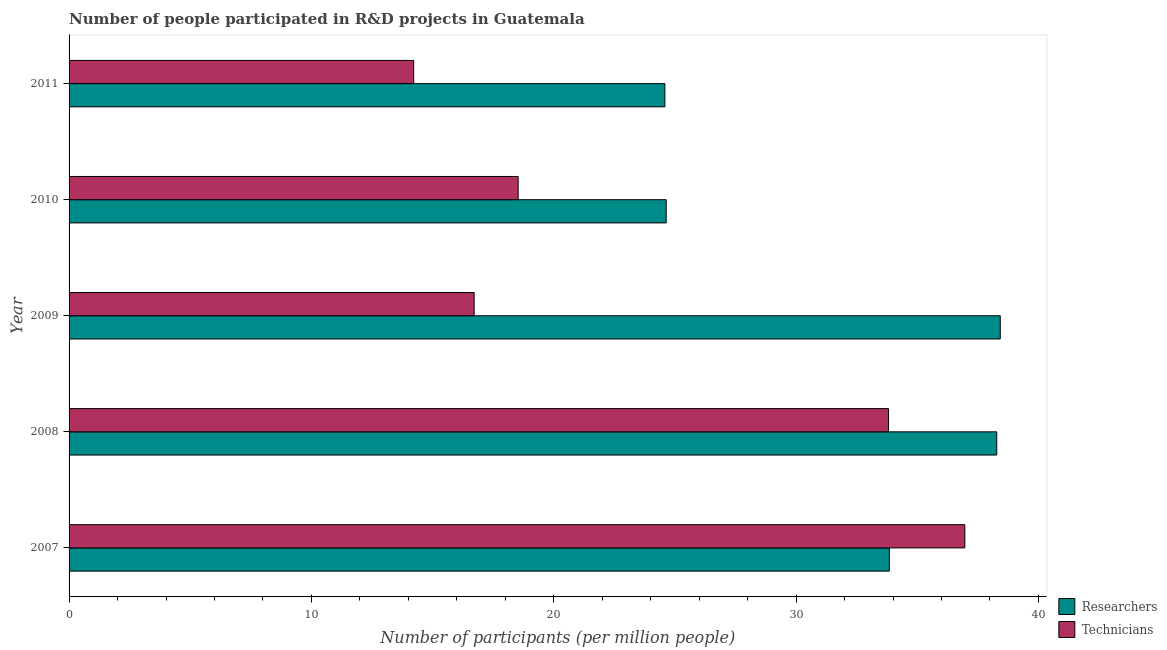How many different coloured bars are there?
Your answer should be compact. 2. How many groups of bars are there?
Offer a very short reply. 5. Are the number of bars per tick equal to the number of legend labels?
Offer a very short reply. Yes. Are the number of bars on each tick of the Y-axis equal?
Keep it short and to the point. Yes. How many bars are there on the 3rd tick from the bottom?
Your answer should be very brief. 2. What is the number of technicians in 2008?
Provide a succinct answer. 33.81. Across all years, what is the maximum number of researchers?
Give a very brief answer. 38.42. Across all years, what is the minimum number of technicians?
Offer a very short reply. 14.22. In which year was the number of researchers maximum?
Keep it short and to the point. 2009. What is the total number of researchers in the graph?
Keep it short and to the point. 159.78. What is the difference between the number of technicians in 2007 and that in 2009?
Your answer should be compact. 20.25. What is the difference between the number of researchers in 2011 and the number of technicians in 2009?
Provide a short and direct response. 7.87. What is the average number of researchers per year?
Your response must be concise. 31.95. In the year 2007, what is the difference between the number of researchers and number of technicians?
Provide a succinct answer. -3.12. In how many years, is the number of technicians greater than 2 ?
Make the answer very short. 5. What is the ratio of the number of technicians in 2007 to that in 2008?
Provide a succinct answer. 1.09. Is the number of technicians in 2009 less than that in 2011?
Your answer should be compact. No. Is the difference between the number of technicians in 2008 and 2011 greater than the difference between the number of researchers in 2008 and 2011?
Provide a short and direct response. Yes. What is the difference between the highest and the second highest number of researchers?
Your response must be concise. 0.14. What is the difference between the highest and the lowest number of technicians?
Keep it short and to the point. 22.74. What does the 1st bar from the top in 2011 represents?
Provide a succinct answer. Technicians. What does the 2nd bar from the bottom in 2010 represents?
Offer a very short reply. Technicians. Are all the bars in the graph horizontal?
Offer a terse response. Yes. What is the difference between two consecutive major ticks on the X-axis?
Ensure brevity in your answer.  10. Are the values on the major ticks of X-axis written in scientific E-notation?
Provide a succinct answer. No. Does the graph contain any zero values?
Your answer should be very brief. No. Does the graph contain grids?
Provide a succinct answer. No. Where does the legend appear in the graph?
Ensure brevity in your answer.  Bottom right. How many legend labels are there?
Ensure brevity in your answer.  2. How are the legend labels stacked?
Offer a terse response. Vertical. What is the title of the graph?
Your answer should be very brief. Number of people participated in R&D projects in Guatemala. What is the label or title of the X-axis?
Provide a succinct answer. Number of participants (per million people). What is the Number of participants (per million people) of Researchers in 2007?
Offer a very short reply. 33.85. What is the Number of participants (per million people) in Technicians in 2007?
Provide a short and direct response. 36.96. What is the Number of participants (per million people) in Researchers in 2008?
Keep it short and to the point. 38.28. What is the Number of participants (per million people) in Technicians in 2008?
Offer a very short reply. 33.81. What is the Number of participants (per million people) in Researchers in 2009?
Your answer should be very brief. 38.42. What is the Number of participants (per million people) of Technicians in 2009?
Your response must be concise. 16.72. What is the Number of participants (per million people) in Researchers in 2010?
Offer a terse response. 24.64. What is the Number of participants (per million people) of Technicians in 2010?
Your answer should be very brief. 18.53. What is the Number of participants (per million people) in Researchers in 2011?
Ensure brevity in your answer.  24.59. What is the Number of participants (per million people) in Technicians in 2011?
Provide a short and direct response. 14.22. Across all years, what is the maximum Number of participants (per million people) in Researchers?
Ensure brevity in your answer.  38.42. Across all years, what is the maximum Number of participants (per million people) in Technicians?
Offer a very short reply. 36.96. Across all years, what is the minimum Number of participants (per million people) of Researchers?
Offer a terse response. 24.59. Across all years, what is the minimum Number of participants (per million people) in Technicians?
Your answer should be very brief. 14.22. What is the total Number of participants (per million people) in Researchers in the graph?
Your response must be concise. 159.78. What is the total Number of participants (per million people) in Technicians in the graph?
Provide a short and direct response. 120.24. What is the difference between the Number of participants (per million people) of Researchers in 2007 and that in 2008?
Your answer should be compact. -4.43. What is the difference between the Number of participants (per million people) of Technicians in 2007 and that in 2008?
Provide a succinct answer. 3.15. What is the difference between the Number of participants (per million people) in Researchers in 2007 and that in 2009?
Give a very brief answer. -4.58. What is the difference between the Number of participants (per million people) of Technicians in 2007 and that in 2009?
Offer a terse response. 20.25. What is the difference between the Number of participants (per million people) of Researchers in 2007 and that in 2010?
Provide a succinct answer. 9.21. What is the difference between the Number of participants (per million people) of Technicians in 2007 and that in 2010?
Give a very brief answer. 18.43. What is the difference between the Number of participants (per million people) of Researchers in 2007 and that in 2011?
Your answer should be very brief. 9.26. What is the difference between the Number of participants (per million people) of Technicians in 2007 and that in 2011?
Your answer should be very brief. 22.74. What is the difference between the Number of participants (per million people) of Researchers in 2008 and that in 2009?
Your response must be concise. -0.14. What is the difference between the Number of participants (per million people) of Technicians in 2008 and that in 2009?
Give a very brief answer. 17.1. What is the difference between the Number of participants (per million people) in Researchers in 2008 and that in 2010?
Give a very brief answer. 13.64. What is the difference between the Number of participants (per million people) in Technicians in 2008 and that in 2010?
Give a very brief answer. 15.28. What is the difference between the Number of participants (per million people) in Researchers in 2008 and that in 2011?
Provide a short and direct response. 13.69. What is the difference between the Number of participants (per million people) in Technicians in 2008 and that in 2011?
Offer a terse response. 19.59. What is the difference between the Number of participants (per million people) of Researchers in 2009 and that in 2010?
Keep it short and to the point. 13.78. What is the difference between the Number of participants (per million people) in Technicians in 2009 and that in 2010?
Your answer should be compact. -1.82. What is the difference between the Number of participants (per million people) of Researchers in 2009 and that in 2011?
Keep it short and to the point. 13.84. What is the difference between the Number of participants (per million people) in Technicians in 2009 and that in 2011?
Your response must be concise. 2.5. What is the difference between the Number of participants (per million people) in Researchers in 2010 and that in 2011?
Your answer should be compact. 0.05. What is the difference between the Number of participants (per million people) in Technicians in 2010 and that in 2011?
Ensure brevity in your answer.  4.31. What is the difference between the Number of participants (per million people) in Researchers in 2007 and the Number of participants (per million people) in Technicians in 2008?
Offer a terse response. 0.03. What is the difference between the Number of participants (per million people) in Researchers in 2007 and the Number of participants (per million people) in Technicians in 2009?
Make the answer very short. 17.13. What is the difference between the Number of participants (per million people) in Researchers in 2007 and the Number of participants (per million people) in Technicians in 2010?
Make the answer very short. 15.32. What is the difference between the Number of participants (per million people) of Researchers in 2007 and the Number of participants (per million people) of Technicians in 2011?
Provide a short and direct response. 19.63. What is the difference between the Number of participants (per million people) of Researchers in 2008 and the Number of participants (per million people) of Technicians in 2009?
Your response must be concise. 21.56. What is the difference between the Number of participants (per million people) in Researchers in 2008 and the Number of participants (per million people) in Technicians in 2010?
Your answer should be very brief. 19.75. What is the difference between the Number of participants (per million people) in Researchers in 2008 and the Number of participants (per million people) in Technicians in 2011?
Provide a short and direct response. 24.06. What is the difference between the Number of participants (per million people) of Researchers in 2009 and the Number of participants (per million people) of Technicians in 2010?
Ensure brevity in your answer.  19.89. What is the difference between the Number of participants (per million people) of Researchers in 2009 and the Number of participants (per million people) of Technicians in 2011?
Your answer should be very brief. 24.2. What is the difference between the Number of participants (per million people) in Researchers in 2010 and the Number of participants (per million people) in Technicians in 2011?
Provide a succinct answer. 10.42. What is the average Number of participants (per million people) in Researchers per year?
Offer a very short reply. 31.96. What is the average Number of participants (per million people) of Technicians per year?
Provide a short and direct response. 24.05. In the year 2007, what is the difference between the Number of participants (per million people) in Researchers and Number of participants (per million people) in Technicians?
Your answer should be compact. -3.12. In the year 2008, what is the difference between the Number of participants (per million people) of Researchers and Number of participants (per million people) of Technicians?
Your answer should be very brief. 4.47. In the year 2009, what is the difference between the Number of participants (per million people) in Researchers and Number of participants (per million people) in Technicians?
Your response must be concise. 21.71. In the year 2010, what is the difference between the Number of participants (per million people) in Researchers and Number of participants (per million people) in Technicians?
Offer a very short reply. 6.11. In the year 2011, what is the difference between the Number of participants (per million people) in Researchers and Number of participants (per million people) in Technicians?
Offer a very short reply. 10.37. What is the ratio of the Number of participants (per million people) in Researchers in 2007 to that in 2008?
Make the answer very short. 0.88. What is the ratio of the Number of participants (per million people) in Technicians in 2007 to that in 2008?
Your answer should be very brief. 1.09. What is the ratio of the Number of participants (per million people) in Researchers in 2007 to that in 2009?
Provide a succinct answer. 0.88. What is the ratio of the Number of participants (per million people) in Technicians in 2007 to that in 2009?
Provide a short and direct response. 2.21. What is the ratio of the Number of participants (per million people) of Researchers in 2007 to that in 2010?
Provide a short and direct response. 1.37. What is the ratio of the Number of participants (per million people) of Technicians in 2007 to that in 2010?
Your answer should be very brief. 1.99. What is the ratio of the Number of participants (per million people) of Researchers in 2007 to that in 2011?
Offer a terse response. 1.38. What is the ratio of the Number of participants (per million people) in Technicians in 2007 to that in 2011?
Your answer should be very brief. 2.6. What is the ratio of the Number of participants (per million people) of Researchers in 2008 to that in 2009?
Provide a short and direct response. 1. What is the ratio of the Number of participants (per million people) of Technicians in 2008 to that in 2009?
Your answer should be compact. 2.02. What is the ratio of the Number of participants (per million people) in Researchers in 2008 to that in 2010?
Offer a very short reply. 1.55. What is the ratio of the Number of participants (per million people) in Technicians in 2008 to that in 2010?
Provide a succinct answer. 1.82. What is the ratio of the Number of participants (per million people) in Researchers in 2008 to that in 2011?
Offer a very short reply. 1.56. What is the ratio of the Number of participants (per million people) of Technicians in 2008 to that in 2011?
Offer a very short reply. 2.38. What is the ratio of the Number of participants (per million people) of Researchers in 2009 to that in 2010?
Keep it short and to the point. 1.56. What is the ratio of the Number of participants (per million people) of Technicians in 2009 to that in 2010?
Your answer should be compact. 0.9. What is the ratio of the Number of participants (per million people) of Researchers in 2009 to that in 2011?
Your answer should be very brief. 1.56. What is the ratio of the Number of participants (per million people) in Technicians in 2009 to that in 2011?
Your response must be concise. 1.18. What is the ratio of the Number of participants (per million people) in Researchers in 2010 to that in 2011?
Your answer should be very brief. 1. What is the ratio of the Number of participants (per million people) of Technicians in 2010 to that in 2011?
Offer a very short reply. 1.3. What is the difference between the highest and the second highest Number of participants (per million people) of Researchers?
Your answer should be very brief. 0.14. What is the difference between the highest and the second highest Number of participants (per million people) of Technicians?
Make the answer very short. 3.15. What is the difference between the highest and the lowest Number of participants (per million people) of Researchers?
Your answer should be very brief. 13.84. What is the difference between the highest and the lowest Number of participants (per million people) of Technicians?
Provide a succinct answer. 22.74. 